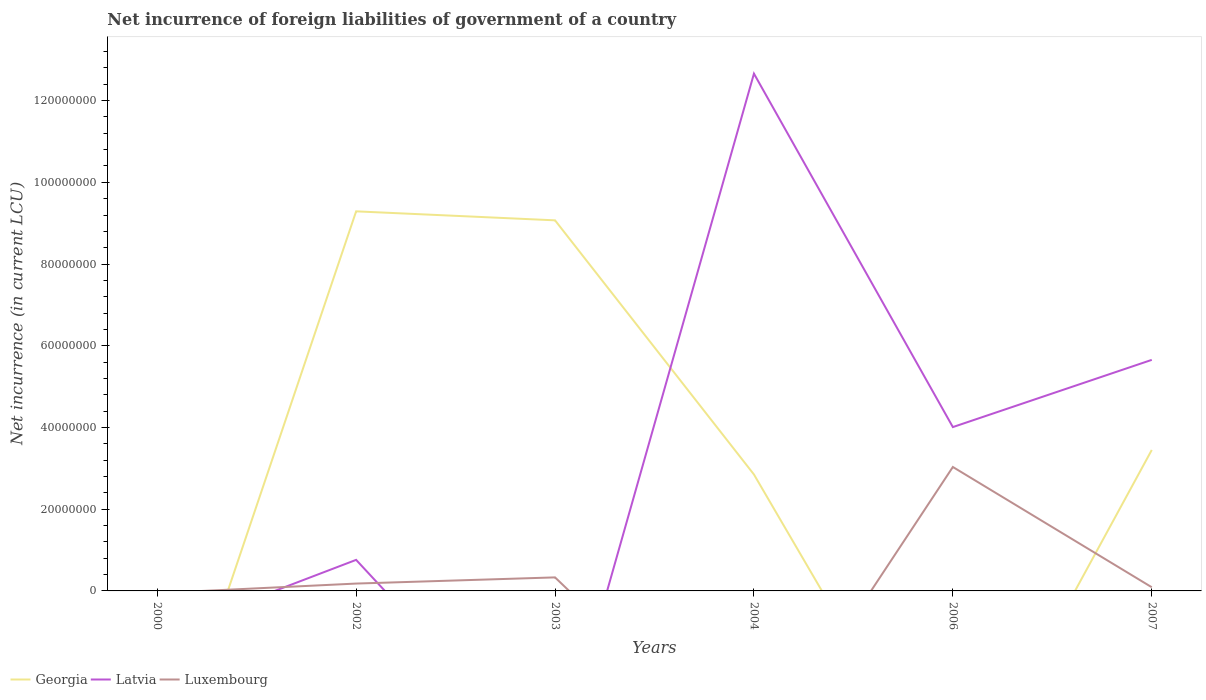How many different coloured lines are there?
Provide a short and direct response. 3. Is the number of lines equal to the number of legend labels?
Ensure brevity in your answer.  No. What is the total net incurrence of foreign liabilities in Georgia in the graph?
Make the answer very short. 6.22e+07. What is the difference between the highest and the second highest net incurrence of foreign liabilities in Luxembourg?
Keep it short and to the point. 3.03e+07. Is the net incurrence of foreign liabilities in Luxembourg strictly greater than the net incurrence of foreign liabilities in Georgia over the years?
Give a very brief answer. No. How many lines are there?
Give a very brief answer. 3. What is the difference between two consecutive major ticks on the Y-axis?
Your response must be concise. 2.00e+07. Where does the legend appear in the graph?
Provide a short and direct response. Bottom left. What is the title of the graph?
Your answer should be compact. Net incurrence of foreign liabilities of government of a country. Does "Bulgaria" appear as one of the legend labels in the graph?
Offer a terse response. No. What is the label or title of the Y-axis?
Provide a short and direct response. Net incurrence (in current LCU). What is the Net incurrence (in current LCU) in Georgia in 2000?
Keep it short and to the point. 0. What is the Net incurrence (in current LCU) in Latvia in 2000?
Offer a terse response. 0. What is the Net incurrence (in current LCU) in Georgia in 2002?
Provide a short and direct response. 9.29e+07. What is the Net incurrence (in current LCU) of Latvia in 2002?
Offer a very short reply. 7.60e+06. What is the Net incurrence (in current LCU) in Luxembourg in 2002?
Your response must be concise. 1.80e+06. What is the Net incurrence (in current LCU) of Georgia in 2003?
Ensure brevity in your answer.  9.07e+07. What is the Net incurrence (in current LCU) in Latvia in 2003?
Your answer should be compact. 0. What is the Net incurrence (in current LCU) in Luxembourg in 2003?
Give a very brief answer. 3.31e+06. What is the Net incurrence (in current LCU) of Georgia in 2004?
Provide a succinct answer. 2.85e+07. What is the Net incurrence (in current LCU) in Latvia in 2004?
Provide a succinct answer. 1.27e+08. What is the Net incurrence (in current LCU) of Luxembourg in 2004?
Provide a succinct answer. 0. What is the Net incurrence (in current LCU) in Latvia in 2006?
Provide a short and direct response. 4.01e+07. What is the Net incurrence (in current LCU) of Luxembourg in 2006?
Your answer should be very brief. 3.03e+07. What is the Net incurrence (in current LCU) in Georgia in 2007?
Your answer should be compact. 3.45e+07. What is the Net incurrence (in current LCU) in Latvia in 2007?
Keep it short and to the point. 5.66e+07. Across all years, what is the maximum Net incurrence (in current LCU) in Georgia?
Provide a succinct answer. 9.29e+07. Across all years, what is the maximum Net incurrence (in current LCU) in Latvia?
Provide a succinct answer. 1.27e+08. Across all years, what is the maximum Net incurrence (in current LCU) of Luxembourg?
Ensure brevity in your answer.  3.03e+07. Across all years, what is the minimum Net incurrence (in current LCU) of Georgia?
Ensure brevity in your answer.  0. Across all years, what is the minimum Net incurrence (in current LCU) in Latvia?
Offer a terse response. 0. What is the total Net incurrence (in current LCU) of Georgia in the graph?
Keep it short and to the point. 2.47e+08. What is the total Net incurrence (in current LCU) of Latvia in the graph?
Make the answer very short. 2.31e+08. What is the total Net incurrence (in current LCU) in Luxembourg in the graph?
Offer a terse response. 3.63e+07. What is the difference between the Net incurrence (in current LCU) in Georgia in 2002 and that in 2003?
Your answer should be very brief. 2.20e+06. What is the difference between the Net incurrence (in current LCU) in Luxembourg in 2002 and that in 2003?
Your response must be concise. -1.51e+06. What is the difference between the Net incurrence (in current LCU) of Georgia in 2002 and that in 2004?
Give a very brief answer. 6.44e+07. What is the difference between the Net incurrence (in current LCU) in Latvia in 2002 and that in 2004?
Provide a succinct answer. -1.19e+08. What is the difference between the Net incurrence (in current LCU) in Latvia in 2002 and that in 2006?
Keep it short and to the point. -3.25e+07. What is the difference between the Net incurrence (in current LCU) in Luxembourg in 2002 and that in 2006?
Ensure brevity in your answer.  -2.85e+07. What is the difference between the Net incurrence (in current LCU) in Georgia in 2002 and that in 2007?
Keep it short and to the point. 5.84e+07. What is the difference between the Net incurrence (in current LCU) of Latvia in 2002 and that in 2007?
Your response must be concise. -4.90e+07. What is the difference between the Net incurrence (in current LCU) of Luxembourg in 2002 and that in 2007?
Offer a terse response. 9.00e+05. What is the difference between the Net incurrence (in current LCU) of Georgia in 2003 and that in 2004?
Make the answer very short. 6.22e+07. What is the difference between the Net incurrence (in current LCU) of Luxembourg in 2003 and that in 2006?
Provide a short and direct response. -2.70e+07. What is the difference between the Net incurrence (in current LCU) in Georgia in 2003 and that in 2007?
Ensure brevity in your answer.  5.62e+07. What is the difference between the Net incurrence (in current LCU) in Luxembourg in 2003 and that in 2007?
Your answer should be very brief. 2.41e+06. What is the difference between the Net incurrence (in current LCU) of Latvia in 2004 and that in 2006?
Your answer should be very brief. 8.65e+07. What is the difference between the Net incurrence (in current LCU) in Georgia in 2004 and that in 2007?
Your response must be concise. -6.00e+06. What is the difference between the Net incurrence (in current LCU) in Latvia in 2004 and that in 2007?
Ensure brevity in your answer.  7.00e+07. What is the difference between the Net incurrence (in current LCU) of Latvia in 2006 and that in 2007?
Offer a terse response. -1.64e+07. What is the difference between the Net incurrence (in current LCU) of Luxembourg in 2006 and that in 2007?
Make the answer very short. 2.94e+07. What is the difference between the Net incurrence (in current LCU) in Georgia in 2002 and the Net incurrence (in current LCU) in Luxembourg in 2003?
Your answer should be very brief. 8.96e+07. What is the difference between the Net incurrence (in current LCU) of Latvia in 2002 and the Net incurrence (in current LCU) of Luxembourg in 2003?
Your answer should be very brief. 4.29e+06. What is the difference between the Net incurrence (in current LCU) of Georgia in 2002 and the Net incurrence (in current LCU) of Latvia in 2004?
Provide a succinct answer. -3.37e+07. What is the difference between the Net incurrence (in current LCU) of Georgia in 2002 and the Net incurrence (in current LCU) of Latvia in 2006?
Offer a very short reply. 5.28e+07. What is the difference between the Net incurrence (in current LCU) in Georgia in 2002 and the Net incurrence (in current LCU) in Luxembourg in 2006?
Offer a very short reply. 6.26e+07. What is the difference between the Net incurrence (in current LCU) in Latvia in 2002 and the Net incurrence (in current LCU) in Luxembourg in 2006?
Offer a terse response. -2.27e+07. What is the difference between the Net incurrence (in current LCU) of Georgia in 2002 and the Net incurrence (in current LCU) of Latvia in 2007?
Give a very brief answer. 3.64e+07. What is the difference between the Net incurrence (in current LCU) of Georgia in 2002 and the Net incurrence (in current LCU) of Luxembourg in 2007?
Make the answer very short. 9.20e+07. What is the difference between the Net incurrence (in current LCU) of Latvia in 2002 and the Net incurrence (in current LCU) of Luxembourg in 2007?
Provide a short and direct response. 6.70e+06. What is the difference between the Net incurrence (in current LCU) of Georgia in 2003 and the Net incurrence (in current LCU) of Latvia in 2004?
Offer a very short reply. -3.59e+07. What is the difference between the Net incurrence (in current LCU) of Georgia in 2003 and the Net incurrence (in current LCU) of Latvia in 2006?
Offer a terse response. 5.06e+07. What is the difference between the Net incurrence (in current LCU) of Georgia in 2003 and the Net incurrence (in current LCU) of Luxembourg in 2006?
Ensure brevity in your answer.  6.04e+07. What is the difference between the Net incurrence (in current LCU) in Georgia in 2003 and the Net incurrence (in current LCU) in Latvia in 2007?
Your response must be concise. 3.42e+07. What is the difference between the Net incurrence (in current LCU) in Georgia in 2003 and the Net incurrence (in current LCU) in Luxembourg in 2007?
Make the answer very short. 8.98e+07. What is the difference between the Net incurrence (in current LCU) of Georgia in 2004 and the Net incurrence (in current LCU) of Latvia in 2006?
Keep it short and to the point. -1.16e+07. What is the difference between the Net incurrence (in current LCU) in Georgia in 2004 and the Net incurrence (in current LCU) in Luxembourg in 2006?
Provide a short and direct response. -1.83e+06. What is the difference between the Net incurrence (in current LCU) in Latvia in 2004 and the Net incurrence (in current LCU) in Luxembourg in 2006?
Your answer should be compact. 9.63e+07. What is the difference between the Net incurrence (in current LCU) of Georgia in 2004 and the Net incurrence (in current LCU) of Latvia in 2007?
Your answer should be compact. -2.80e+07. What is the difference between the Net incurrence (in current LCU) in Georgia in 2004 and the Net incurrence (in current LCU) in Luxembourg in 2007?
Make the answer very short. 2.76e+07. What is the difference between the Net incurrence (in current LCU) in Latvia in 2004 and the Net incurrence (in current LCU) in Luxembourg in 2007?
Provide a succinct answer. 1.26e+08. What is the difference between the Net incurrence (in current LCU) of Latvia in 2006 and the Net incurrence (in current LCU) of Luxembourg in 2007?
Keep it short and to the point. 3.92e+07. What is the average Net incurrence (in current LCU) of Georgia per year?
Offer a very short reply. 4.11e+07. What is the average Net incurrence (in current LCU) in Latvia per year?
Your response must be concise. 3.85e+07. What is the average Net incurrence (in current LCU) in Luxembourg per year?
Your answer should be very brief. 6.06e+06. In the year 2002, what is the difference between the Net incurrence (in current LCU) in Georgia and Net incurrence (in current LCU) in Latvia?
Give a very brief answer. 8.53e+07. In the year 2002, what is the difference between the Net incurrence (in current LCU) in Georgia and Net incurrence (in current LCU) in Luxembourg?
Offer a very short reply. 9.11e+07. In the year 2002, what is the difference between the Net incurrence (in current LCU) of Latvia and Net incurrence (in current LCU) of Luxembourg?
Keep it short and to the point. 5.80e+06. In the year 2003, what is the difference between the Net incurrence (in current LCU) in Georgia and Net incurrence (in current LCU) in Luxembourg?
Provide a short and direct response. 8.74e+07. In the year 2004, what is the difference between the Net incurrence (in current LCU) in Georgia and Net incurrence (in current LCU) in Latvia?
Offer a very short reply. -9.81e+07. In the year 2006, what is the difference between the Net incurrence (in current LCU) of Latvia and Net incurrence (in current LCU) of Luxembourg?
Your response must be concise. 9.77e+06. In the year 2007, what is the difference between the Net incurrence (in current LCU) of Georgia and Net incurrence (in current LCU) of Latvia?
Your answer should be compact. -2.20e+07. In the year 2007, what is the difference between the Net incurrence (in current LCU) in Georgia and Net incurrence (in current LCU) in Luxembourg?
Your answer should be compact. 3.36e+07. In the year 2007, what is the difference between the Net incurrence (in current LCU) of Latvia and Net incurrence (in current LCU) of Luxembourg?
Provide a succinct answer. 5.56e+07. What is the ratio of the Net incurrence (in current LCU) in Georgia in 2002 to that in 2003?
Offer a very short reply. 1.02. What is the ratio of the Net incurrence (in current LCU) of Luxembourg in 2002 to that in 2003?
Ensure brevity in your answer.  0.54. What is the ratio of the Net incurrence (in current LCU) in Georgia in 2002 to that in 2004?
Keep it short and to the point. 3.26. What is the ratio of the Net incurrence (in current LCU) of Latvia in 2002 to that in 2006?
Offer a very short reply. 0.19. What is the ratio of the Net incurrence (in current LCU) in Luxembourg in 2002 to that in 2006?
Your answer should be very brief. 0.06. What is the ratio of the Net incurrence (in current LCU) in Georgia in 2002 to that in 2007?
Offer a very short reply. 2.69. What is the ratio of the Net incurrence (in current LCU) of Latvia in 2002 to that in 2007?
Your response must be concise. 0.13. What is the ratio of the Net incurrence (in current LCU) of Luxembourg in 2002 to that in 2007?
Your answer should be very brief. 2. What is the ratio of the Net incurrence (in current LCU) of Georgia in 2003 to that in 2004?
Keep it short and to the point. 3.18. What is the ratio of the Net incurrence (in current LCU) of Luxembourg in 2003 to that in 2006?
Give a very brief answer. 0.11. What is the ratio of the Net incurrence (in current LCU) of Georgia in 2003 to that in 2007?
Make the answer very short. 2.63. What is the ratio of the Net incurrence (in current LCU) in Luxembourg in 2003 to that in 2007?
Your answer should be compact. 3.68. What is the ratio of the Net incurrence (in current LCU) in Latvia in 2004 to that in 2006?
Provide a succinct answer. 3.16. What is the ratio of the Net incurrence (in current LCU) of Georgia in 2004 to that in 2007?
Give a very brief answer. 0.83. What is the ratio of the Net incurrence (in current LCU) in Latvia in 2004 to that in 2007?
Give a very brief answer. 2.24. What is the ratio of the Net incurrence (in current LCU) of Latvia in 2006 to that in 2007?
Make the answer very short. 0.71. What is the ratio of the Net incurrence (in current LCU) in Luxembourg in 2006 to that in 2007?
Your response must be concise. 33.7. What is the difference between the highest and the second highest Net incurrence (in current LCU) of Georgia?
Provide a short and direct response. 2.20e+06. What is the difference between the highest and the second highest Net incurrence (in current LCU) in Latvia?
Your response must be concise. 7.00e+07. What is the difference between the highest and the second highest Net incurrence (in current LCU) of Luxembourg?
Offer a terse response. 2.70e+07. What is the difference between the highest and the lowest Net incurrence (in current LCU) in Georgia?
Offer a very short reply. 9.29e+07. What is the difference between the highest and the lowest Net incurrence (in current LCU) in Latvia?
Provide a succinct answer. 1.27e+08. What is the difference between the highest and the lowest Net incurrence (in current LCU) of Luxembourg?
Make the answer very short. 3.03e+07. 